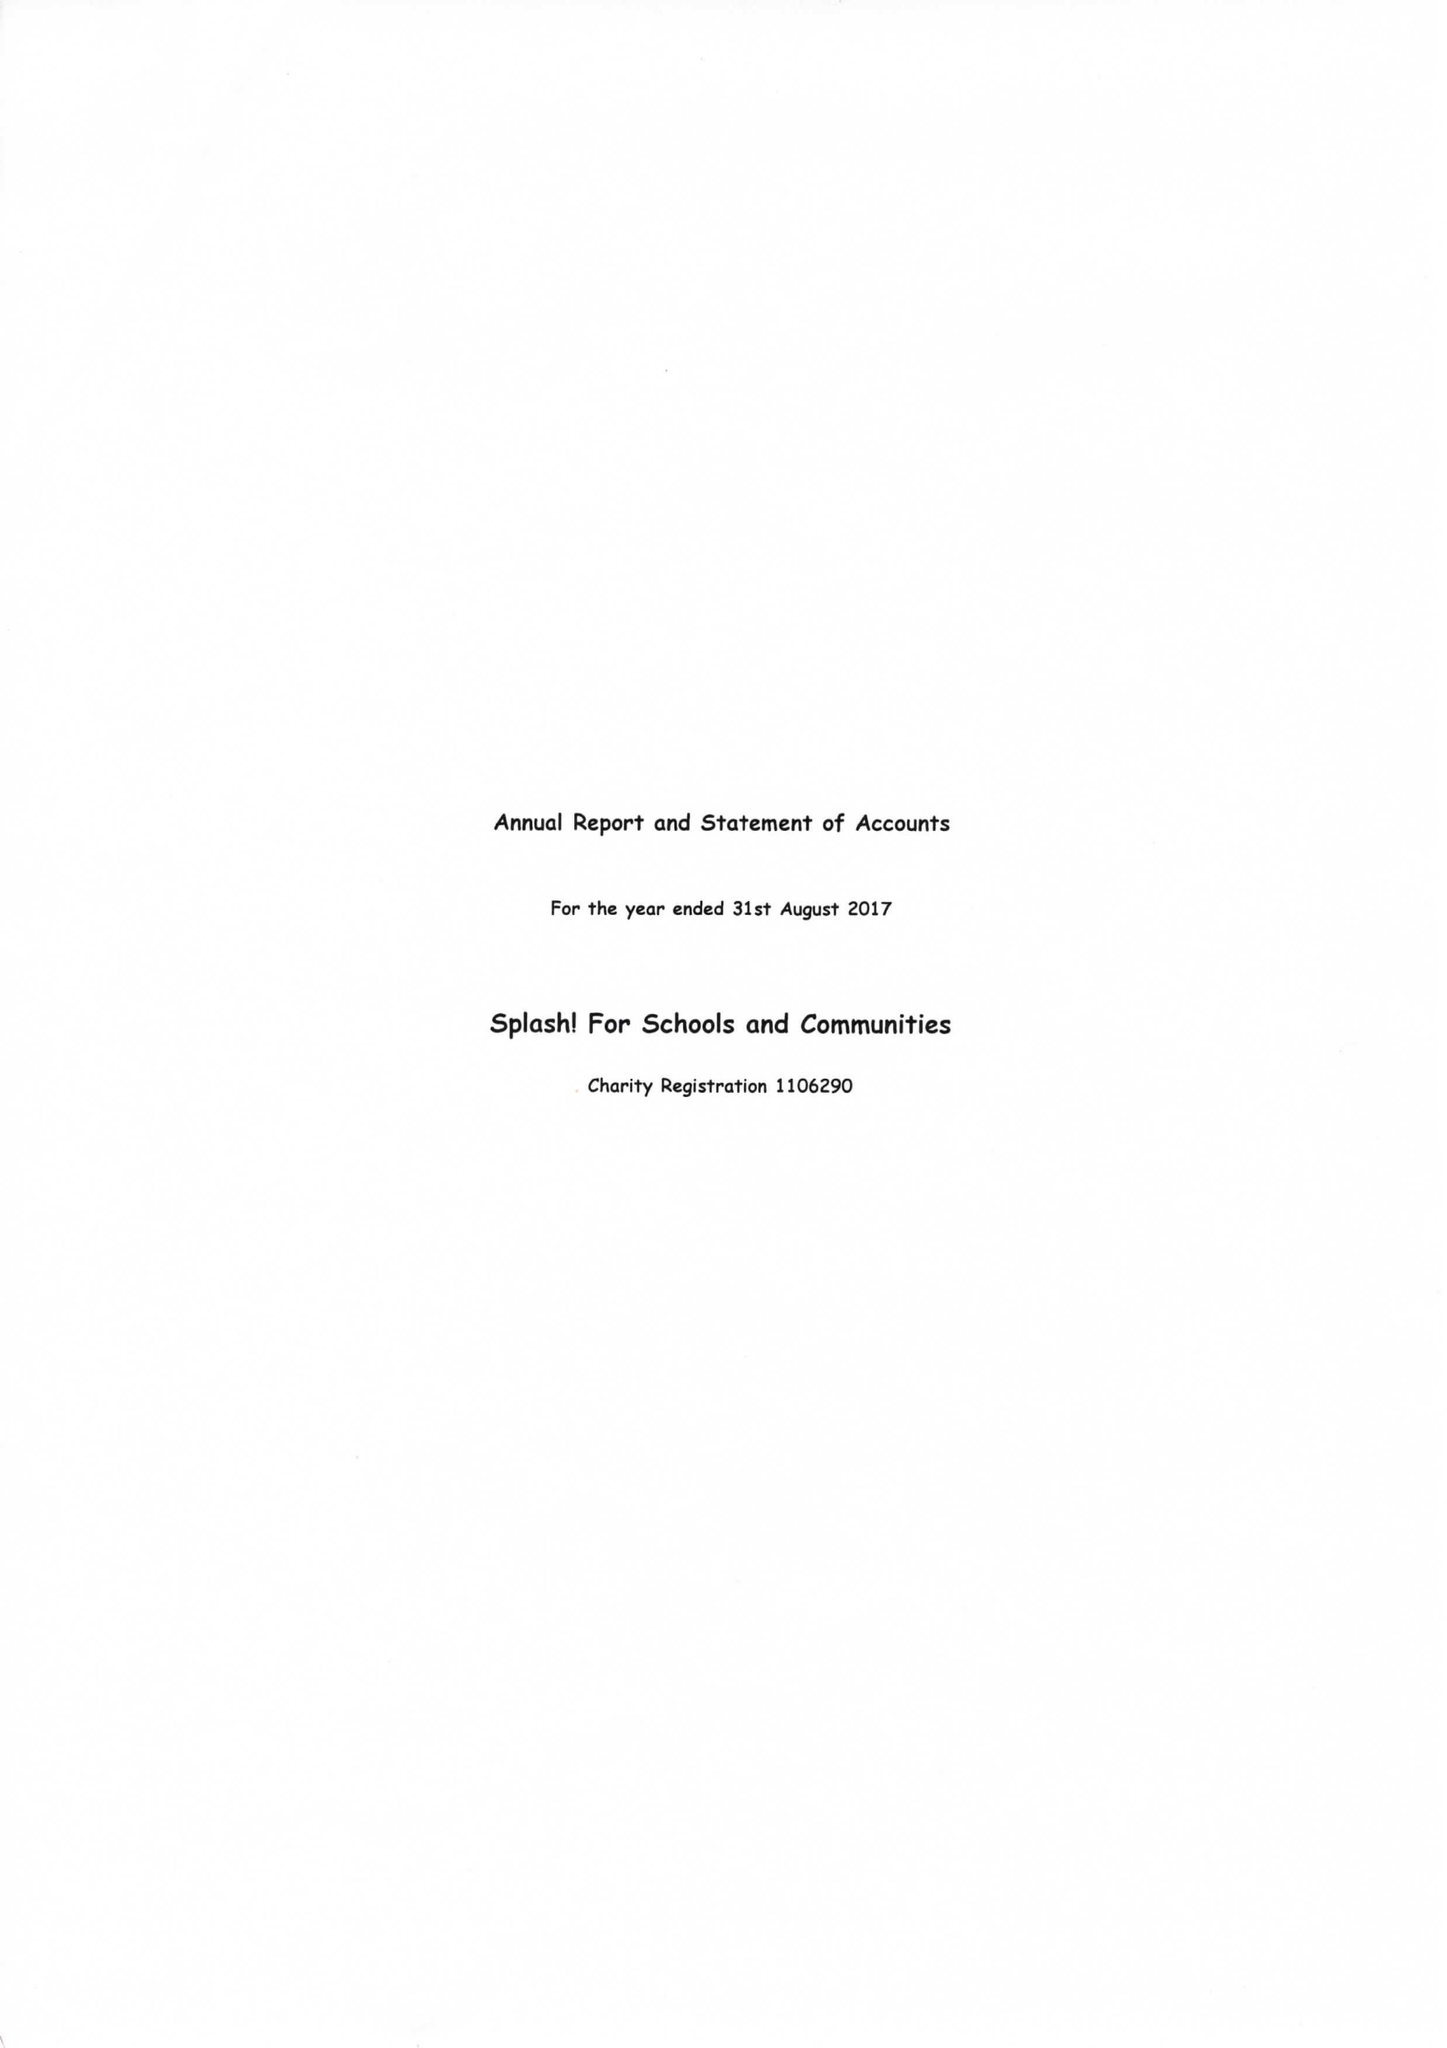What is the value for the address__post_town?
Answer the question using a single word or phrase. PULBOROUGH 